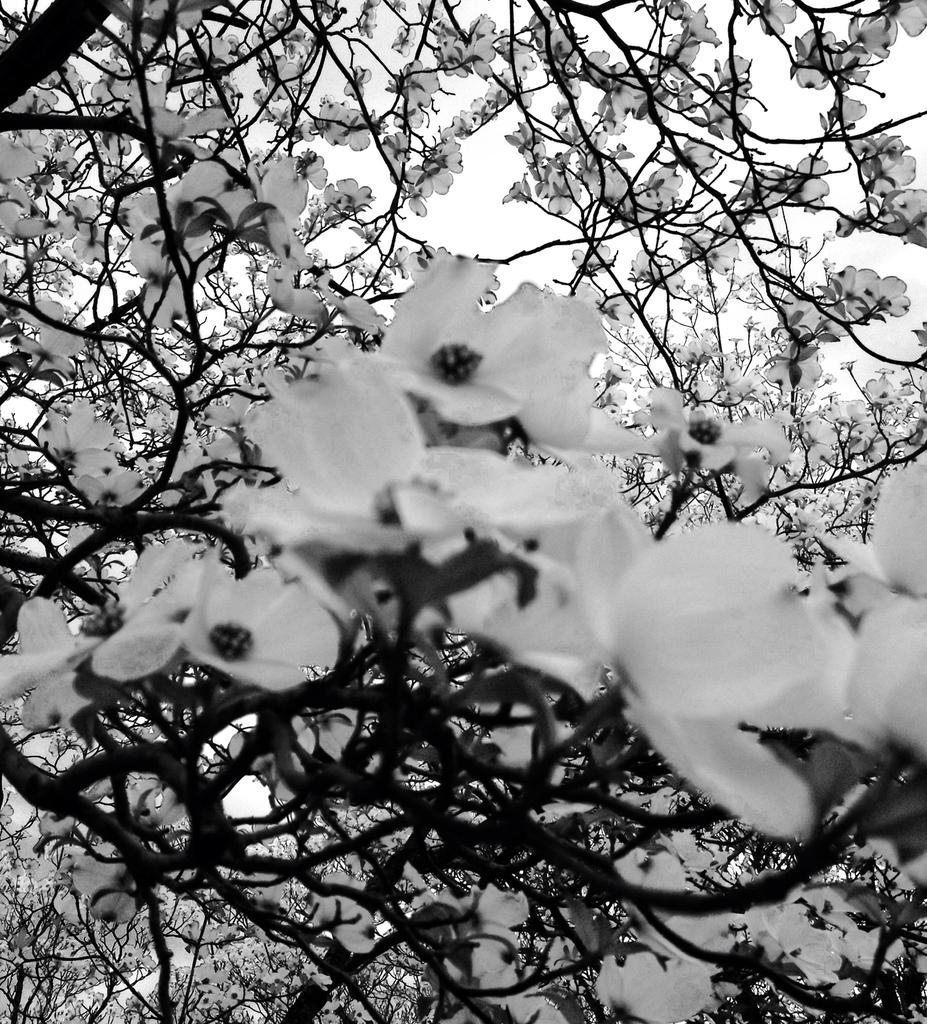What type of plants can be seen in the image? There are flower plants in the image. What is the color scheme of the image? The image is black and white. Can you see any ants crawling on the flower plants in the image? There is no indication of ants or any other insects in the image, as it is a black and white image of flower plants. 